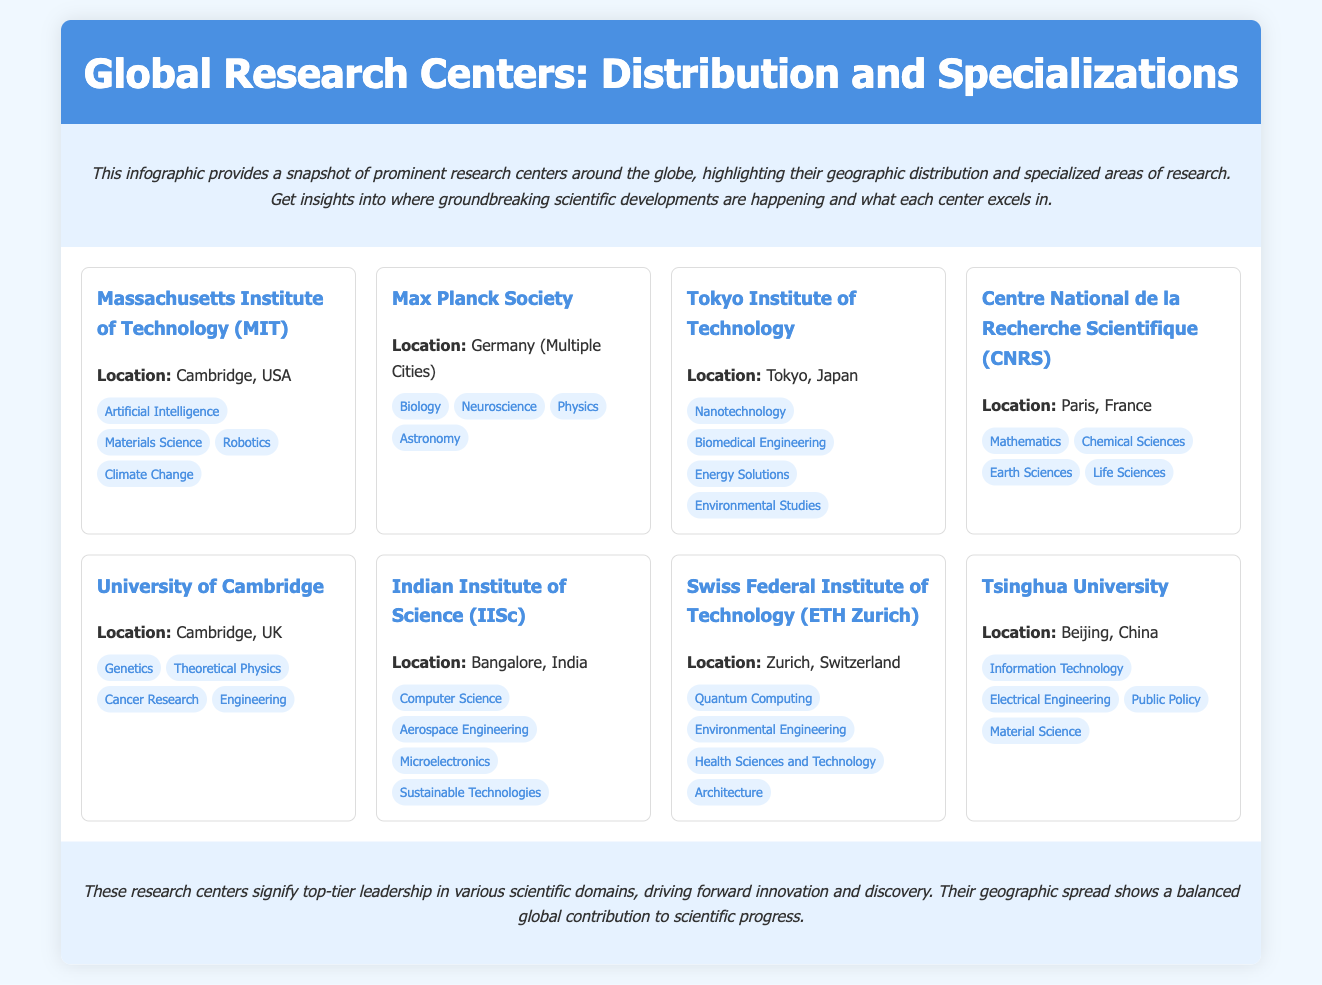What is the location of Massachusetts Institute of Technology (MIT)? The document states that MIT is located in Cambridge, USA.
Answer: Cambridge, USA Which specialization is associated with Tokyo Institute of Technology? The infographic lists several specializations for Tokyo Institute of Technology, including Nanotechnology, Biomedical Engineering, Energy Solutions, and Environmental Studies.
Answer: Nanotechnology How many research centers are mentioned in the document? The document lists a total of eight research centers.
Answer: 8 What geographical area does the Max Planck Society cover? The document specifies that the Max Planck Society is located in Germany across multiple cities.
Answer: Germany (Multiple Cities) Which center specializes in Quantum Computing? The infographic specifically mentions the Swiss Federal Institute of Technology (ETH Zurich) as specializing in Quantum Computing.
Answer: ETH Zurich Which two countries are represented by research centers in this infographic? The document includes research centers from the USA and India.
Answer: USA and India What type of infographic is this? The document is identified as a geographic infographic focused on Global Research Centers.
Answer: Geographic infographic Which research center focuses on Cancer Research? The University of Cambridge is highlighted in the document as having a specialization in Cancer Research.
Answer: University of Cambridge 